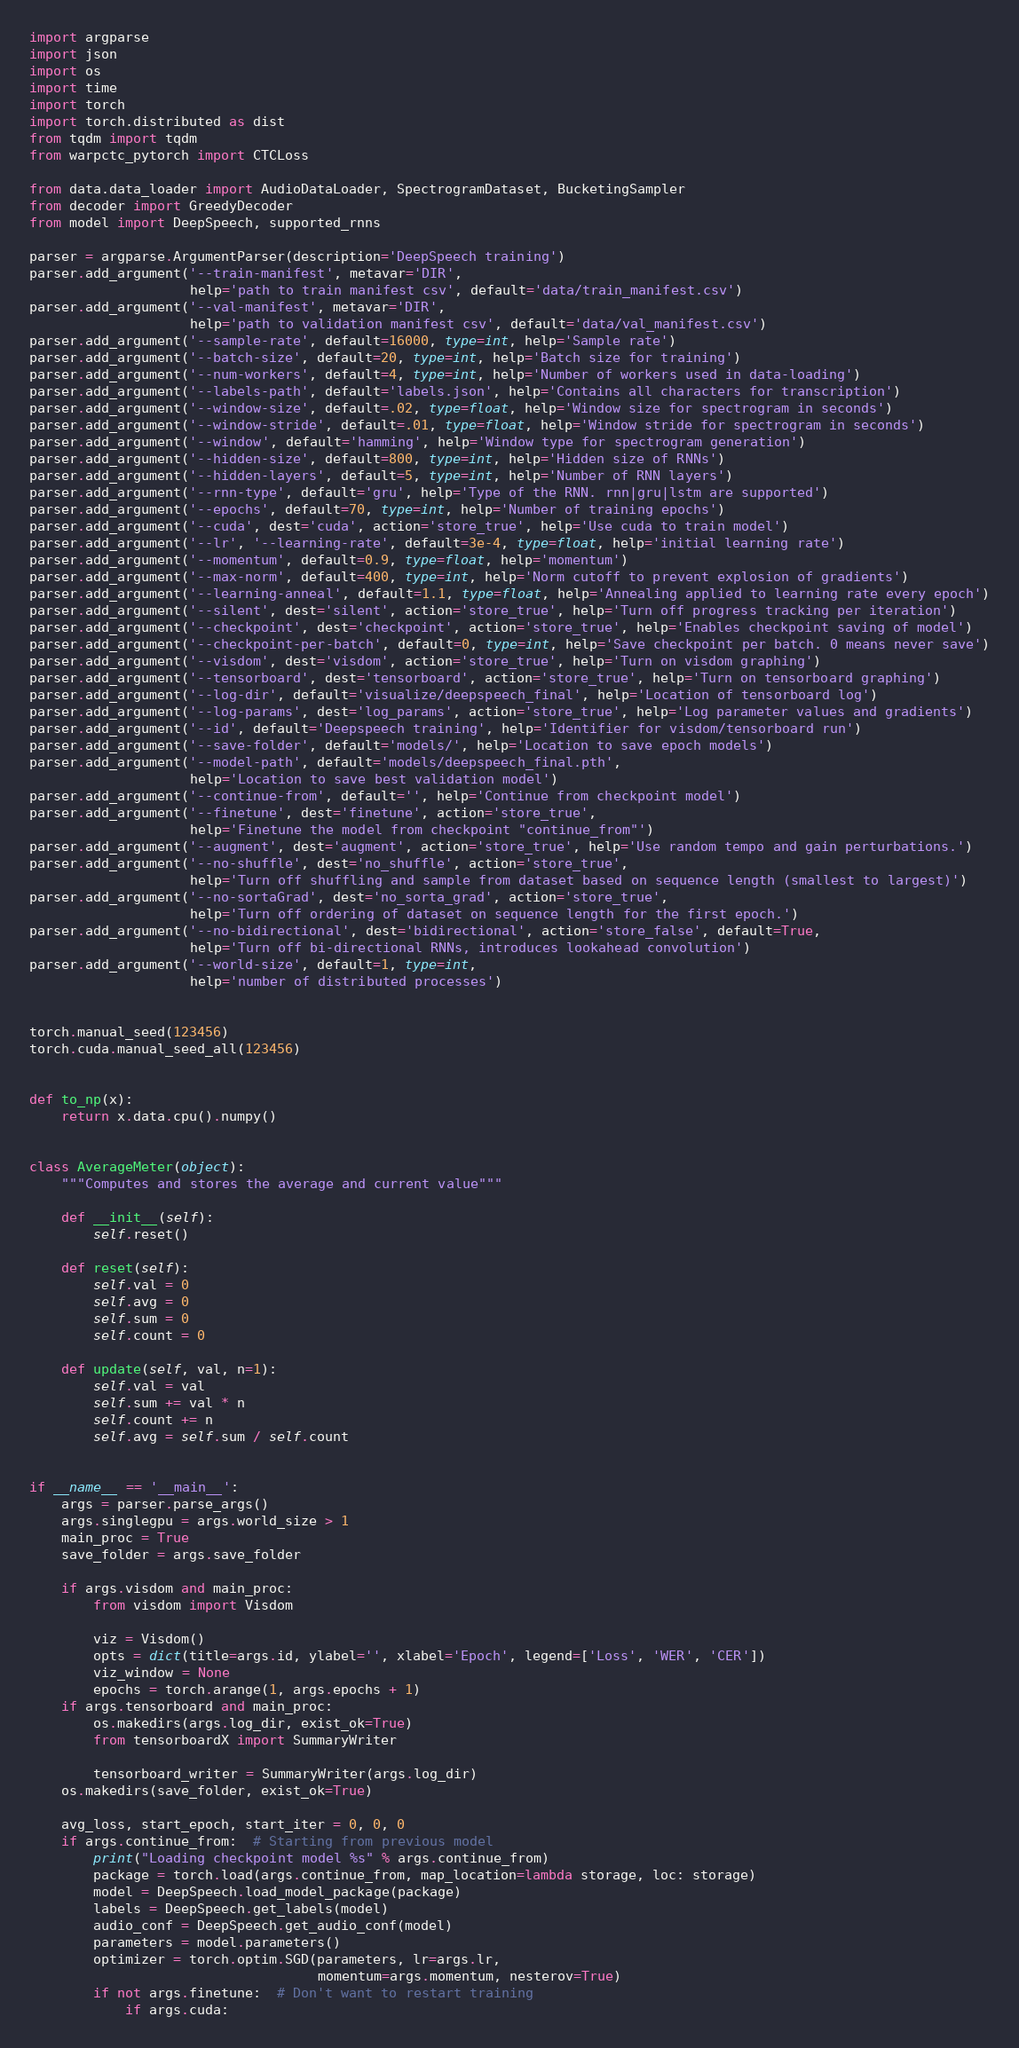<code> <loc_0><loc_0><loc_500><loc_500><_Python_>import argparse
import json
import os
import time
import torch
import torch.distributed as dist
from tqdm import tqdm
from warpctc_pytorch import CTCLoss

from data.data_loader import AudioDataLoader, SpectrogramDataset, BucketingSampler
from decoder import GreedyDecoder
from model import DeepSpeech, supported_rnns

parser = argparse.ArgumentParser(description='DeepSpeech training')
parser.add_argument('--train-manifest', metavar='DIR',
                    help='path to train manifest csv', default='data/train_manifest.csv')
parser.add_argument('--val-manifest', metavar='DIR',
                    help='path to validation manifest csv', default='data/val_manifest.csv')
parser.add_argument('--sample-rate', default=16000, type=int, help='Sample rate')
parser.add_argument('--batch-size', default=20, type=int, help='Batch size for training')
parser.add_argument('--num-workers', default=4, type=int, help='Number of workers used in data-loading')
parser.add_argument('--labels-path', default='labels.json', help='Contains all characters for transcription')
parser.add_argument('--window-size', default=.02, type=float, help='Window size for spectrogram in seconds')
parser.add_argument('--window-stride', default=.01, type=float, help='Window stride for spectrogram in seconds')
parser.add_argument('--window', default='hamming', help='Window type for spectrogram generation')
parser.add_argument('--hidden-size', default=800, type=int, help='Hidden size of RNNs')
parser.add_argument('--hidden-layers', default=5, type=int, help='Number of RNN layers')
parser.add_argument('--rnn-type', default='gru', help='Type of the RNN. rnn|gru|lstm are supported')
parser.add_argument('--epochs', default=70, type=int, help='Number of training epochs')
parser.add_argument('--cuda', dest='cuda', action='store_true', help='Use cuda to train model')
parser.add_argument('--lr', '--learning-rate', default=3e-4, type=float, help='initial learning rate')
parser.add_argument('--momentum', default=0.9, type=float, help='momentum')
parser.add_argument('--max-norm', default=400, type=int, help='Norm cutoff to prevent explosion of gradients')
parser.add_argument('--learning-anneal', default=1.1, type=float, help='Annealing applied to learning rate every epoch')
parser.add_argument('--silent', dest='silent', action='store_true', help='Turn off progress tracking per iteration')
parser.add_argument('--checkpoint', dest='checkpoint', action='store_true', help='Enables checkpoint saving of model')
parser.add_argument('--checkpoint-per-batch', default=0, type=int, help='Save checkpoint per batch. 0 means never save')
parser.add_argument('--visdom', dest='visdom', action='store_true', help='Turn on visdom graphing')
parser.add_argument('--tensorboard', dest='tensorboard', action='store_true', help='Turn on tensorboard graphing')
parser.add_argument('--log-dir', default='visualize/deepspeech_final', help='Location of tensorboard log')
parser.add_argument('--log-params', dest='log_params', action='store_true', help='Log parameter values and gradients')
parser.add_argument('--id', default='Deepspeech training', help='Identifier for visdom/tensorboard run')
parser.add_argument('--save-folder', default='models/', help='Location to save epoch models')
parser.add_argument('--model-path', default='models/deepspeech_final.pth',
                    help='Location to save best validation model')
parser.add_argument('--continue-from', default='', help='Continue from checkpoint model')
parser.add_argument('--finetune', dest='finetune', action='store_true',
                    help='Finetune the model from checkpoint "continue_from"')
parser.add_argument('--augment', dest='augment', action='store_true', help='Use random tempo and gain perturbations.')
parser.add_argument('--no-shuffle', dest='no_shuffle', action='store_true',
                    help='Turn off shuffling and sample from dataset based on sequence length (smallest to largest)')
parser.add_argument('--no-sortaGrad', dest='no_sorta_grad', action='store_true',
                    help='Turn off ordering of dataset on sequence length for the first epoch.')
parser.add_argument('--no-bidirectional', dest='bidirectional', action='store_false', default=True,
                    help='Turn off bi-directional RNNs, introduces lookahead convolution')
parser.add_argument('--world-size', default=1, type=int,
                    help='number of distributed processes')


torch.manual_seed(123456)
torch.cuda.manual_seed_all(123456)


def to_np(x):
    return x.data.cpu().numpy()


class AverageMeter(object):
    """Computes and stores the average and current value"""

    def __init__(self):
        self.reset()

    def reset(self):
        self.val = 0
        self.avg = 0
        self.sum = 0
        self.count = 0

    def update(self, val, n=1):
        self.val = val
        self.sum += val * n
        self.count += n
        self.avg = self.sum / self.count


if __name__ == '__main__':
    args = parser.parse_args()
    args.singlegpu = args.world_size > 1
    main_proc = True
    save_folder = args.save_folder
   
    if args.visdom and main_proc:
        from visdom import Visdom

        viz = Visdom()
        opts = dict(title=args.id, ylabel='', xlabel='Epoch', legend=['Loss', 'WER', 'CER'])
        viz_window = None
        epochs = torch.arange(1, args.epochs + 1)
    if args.tensorboard and main_proc:
        os.makedirs(args.log_dir, exist_ok=True)
        from tensorboardX import SummaryWriter

        tensorboard_writer = SummaryWriter(args.log_dir)
    os.makedirs(save_folder, exist_ok=True)

    avg_loss, start_epoch, start_iter = 0, 0, 0
    if args.continue_from:  # Starting from previous model
        print("Loading checkpoint model %s" % args.continue_from)
        package = torch.load(args.continue_from, map_location=lambda storage, loc: storage)
        model = DeepSpeech.load_model_package(package)
        labels = DeepSpeech.get_labels(model)
        audio_conf = DeepSpeech.get_audio_conf(model)
        parameters = model.parameters()
        optimizer = torch.optim.SGD(parameters, lr=args.lr,
                                    momentum=args.momentum, nesterov=True)
        if not args.finetune:  # Don't want to restart training
            if args.cuda:</code> 